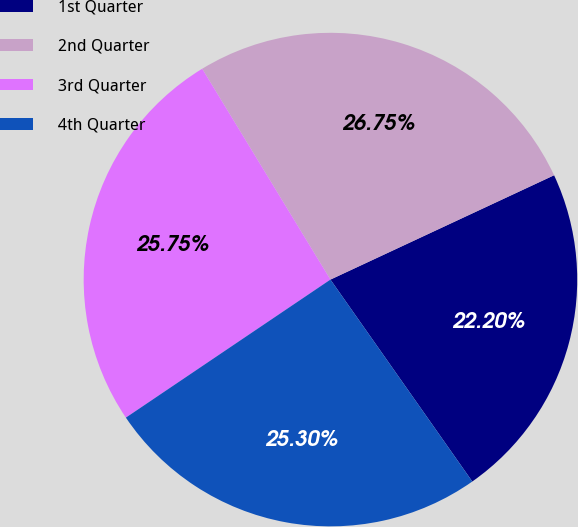<chart> <loc_0><loc_0><loc_500><loc_500><pie_chart><fcel>1st Quarter<fcel>2nd Quarter<fcel>3rd Quarter<fcel>4th Quarter<nl><fcel>22.2%<fcel>26.75%<fcel>25.75%<fcel>25.3%<nl></chart> 